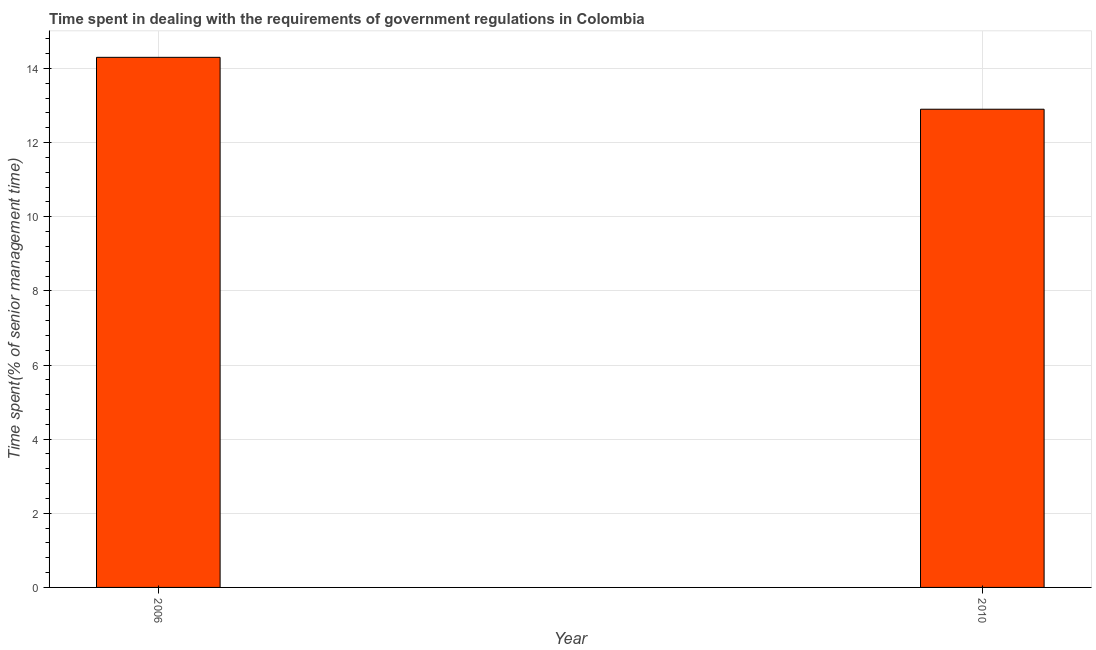Does the graph contain grids?
Your answer should be compact. Yes. What is the title of the graph?
Ensure brevity in your answer.  Time spent in dealing with the requirements of government regulations in Colombia. What is the label or title of the X-axis?
Your answer should be very brief. Year. What is the label or title of the Y-axis?
Ensure brevity in your answer.  Time spent(% of senior management time). What is the time spent in dealing with government regulations in 2010?
Your answer should be very brief. 12.9. Across all years, what is the maximum time spent in dealing with government regulations?
Keep it short and to the point. 14.3. What is the sum of the time spent in dealing with government regulations?
Your answer should be compact. 27.2. What is the average time spent in dealing with government regulations per year?
Keep it short and to the point. 13.6. What is the median time spent in dealing with government regulations?
Give a very brief answer. 13.6. What is the ratio of the time spent in dealing with government regulations in 2006 to that in 2010?
Your answer should be very brief. 1.11. Is the time spent in dealing with government regulations in 2006 less than that in 2010?
Give a very brief answer. No. In how many years, is the time spent in dealing with government regulations greater than the average time spent in dealing with government regulations taken over all years?
Ensure brevity in your answer.  1. How many bars are there?
Your response must be concise. 2. Are all the bars in the graph horizontal?
Offer a very short reply. No. Are the values on the major ticks of Y-axis written in scientific E-notation?
Your answer should be compact. No. What is the ratio of the Time spent(% of senior management time) in 2006 to that in 2010?
Offer a very short reply. 1.11. 